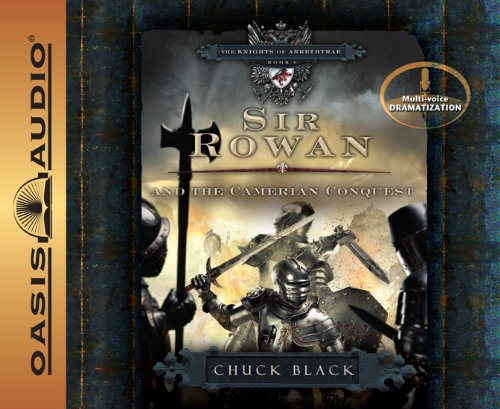Who wrote this book? The book depicted in the image, Sir Rowan and the Camerian Conquest, is authored by Chuck Black, an acclaimed author known for his engaging and imaginative storytelling in the Knights of Arrethtrae series. 